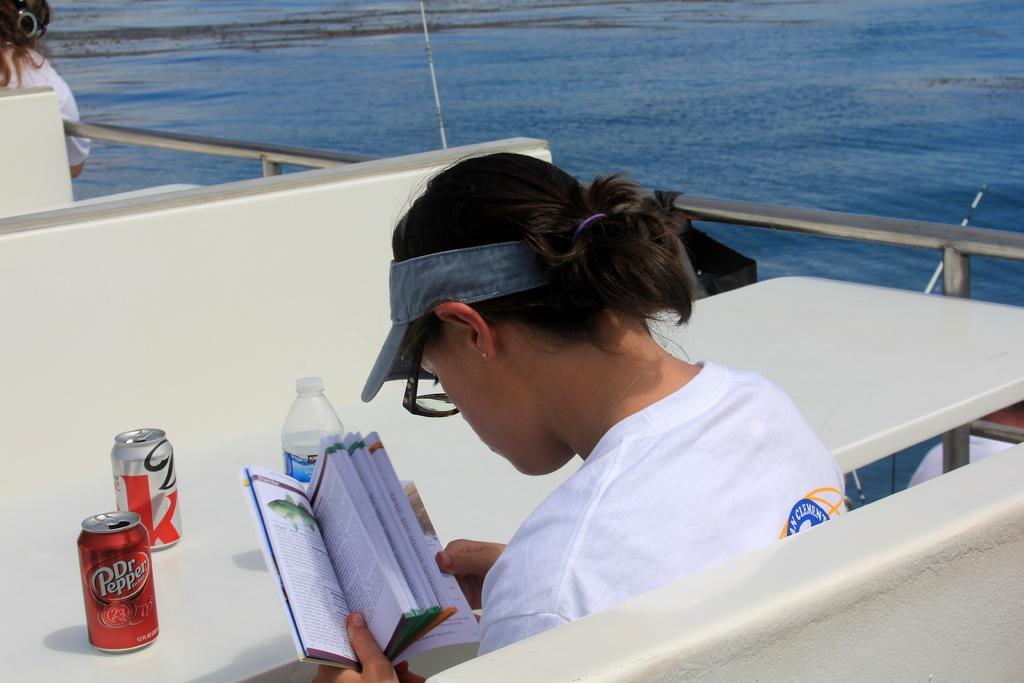Can you describe this image briefly? In this picture there is a woman who is wearing cap, spectacle, white t-shirt and she is reading the book. She was sitting on the bench. In front of her we can see two coke can and a water bottle on the table. At the top we can see water. On the top left corner there is another woman who is standing near to the fencing. 